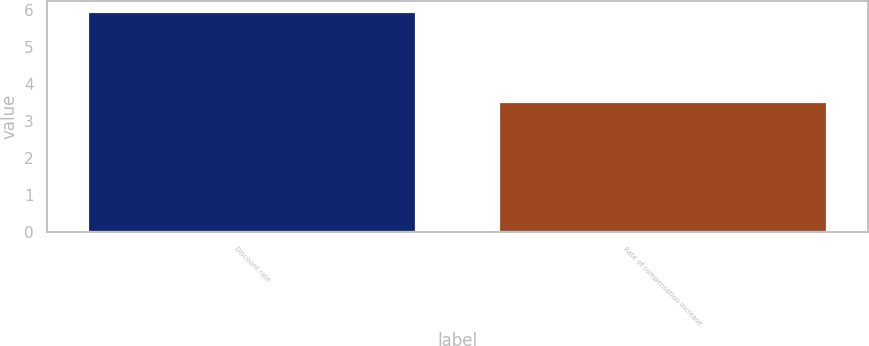<chart> <loc_0><loc_0><loc_500><loc_500><bar_chart><fcel>Discount rate<fcel>Rate of compensation increase<nl><fcel>5.95<fcel>3.5<nl></chart> 